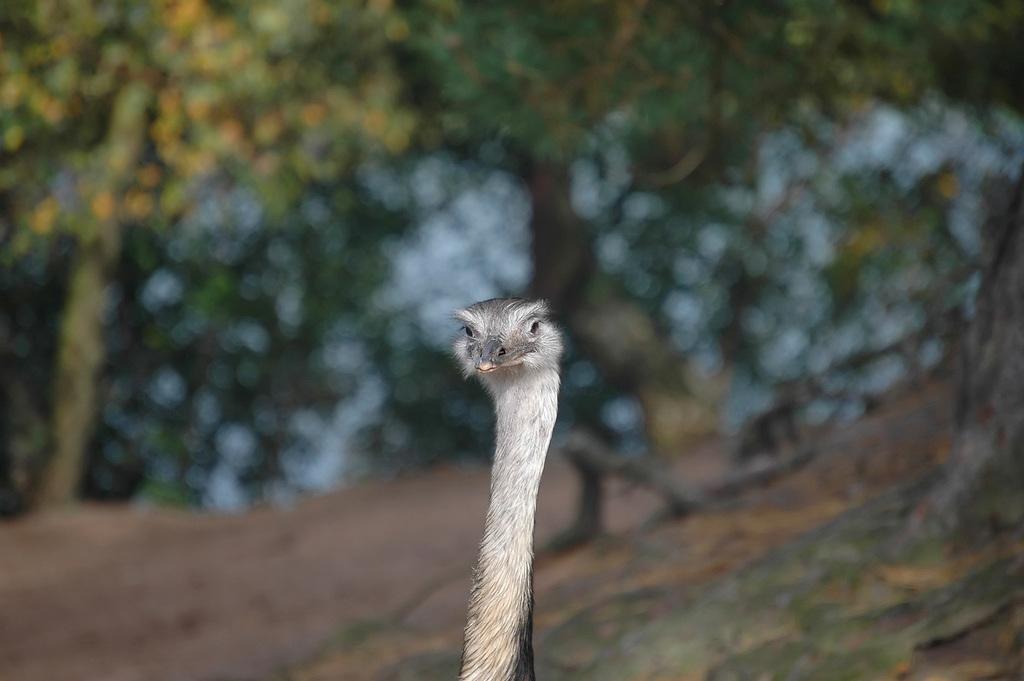Can you describe this image briefly? In the image we can see bird ostrich. In the background, we can see the trees and the background is blurred. 